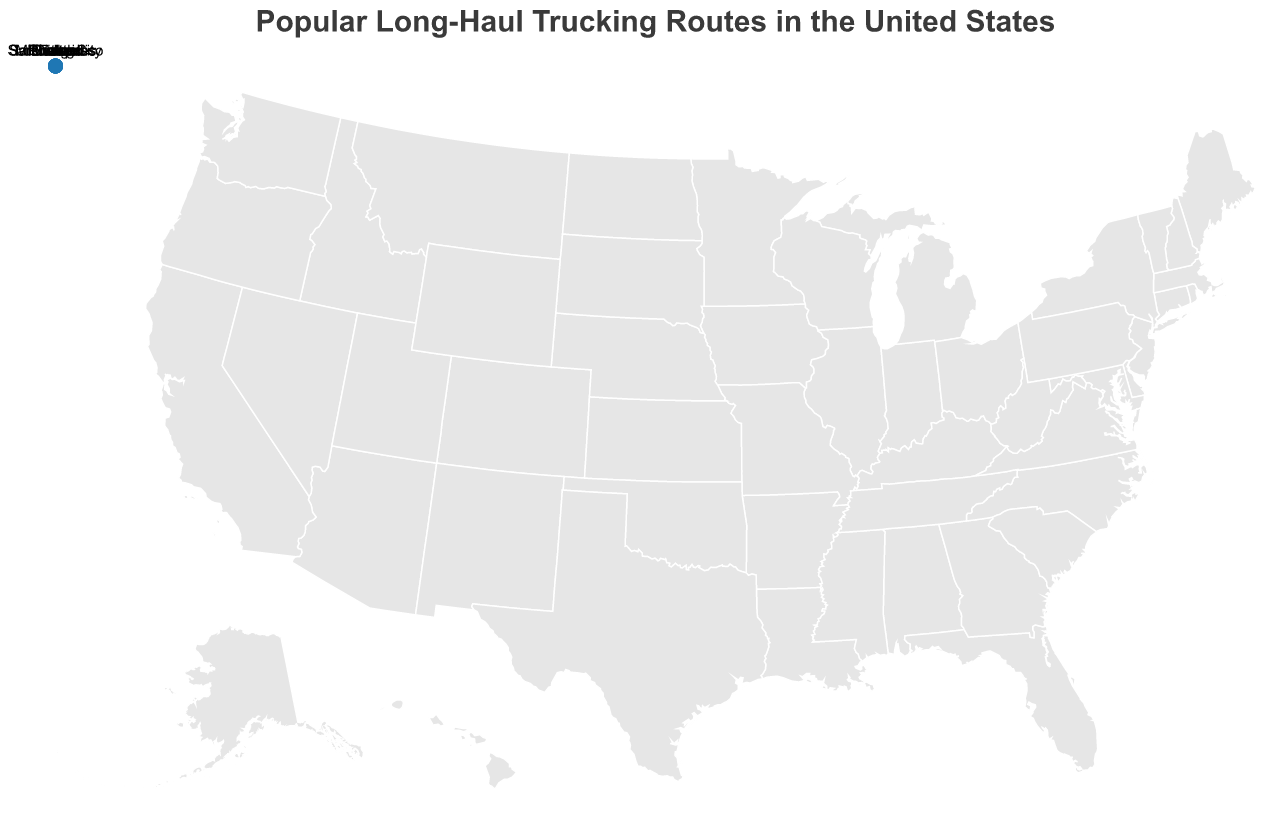What is the average journey time for the route from Los Angeles to New York City? Look for the Los Angeles to New York City route on the figure, and identify the avg_journey_time_hours value associated with it, which is 45 hours
Answer: 45 hours Which route has the longest average journey time? Compare all the avg_journey_time_hours values and identify the maximum value, which is 52 hours for the Seattle to Miami route
Answer: Seattle to Miami Which route has the shortest average journey time? Compare all the avg_journey_time_hours values and identify the minimum value, which is 20 hours for the Chicago to Houston route
Answer: Chicago to Houston How many routes have an average journey time of 40 hours or more? Identify values of avg_journey_time_hours greater than or equal to 40 hours, and count these occurrences
Answer: 6 What is the combined total average journey time for all routes starting from Los Angeles, Seattle, and Phoenix? Sum the avg_journey_time_hours for Los Angeles to New York City (45 hours), Seattle to Miami (52 hours), and Phoenix to Detroit (35 hours)
Answer: 132 hours How many routes start from cities on the West Coast (Los Angeles, San Francisco, Seattle, Portland)? Count the occurrences of West Coast cities (Los Angeles, San Francisco, Seattle, Portland) in the list of origins
Answer: 4 Which East Coast city receives the highest number of routes? Identify the East Coast destinations (New York City, Miami, Boston, Philadelphia, Washington D.C., Orlando) and count the frequency of each; the highest frequency is Philadelphia with 2 routes
Answer: Philadelphia What is the average journey time for routes longer than 30 hours? Identify and sum the avg_journey_time_hours values for routes with times greater than 30 hours (45, 52, 32, 41, 35, 48, 36), then calculate the average (289 / 7)
Answer: ~41.29 hours Which midwestern city is the destination of the longest route originating from the West Coast? From the routes starting from the West Coast (Los Angeles, San Francisco, Seattle, Portland) with a Midwestern destination (Chicago, Minneapolis, Detroit), identify the longest avg_journey_time_hours, which is 35 hours for Phoenix to Detroit
Answer: Detroit How many routes use the I-40 E highway as part of their journey? Count the occurrences of "I-40 E" in the route field, which appear in the routes from Los Angeles to New York (1), San Francisco to Atlanta (1), Phoenix to Detroit (1)
Answer: 3 